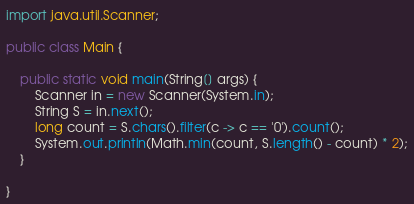Convert code to text. <code><loc_0><loc_0><loc_500><loc_500><_Java_>
import java.util.Scanner;

public class Main {

	public static void main(String[] args) {
		Scanner in = new Scanner(System.in);
		String S = in.next();
		long count = S.chars().filter(c -> c == '0').count();
		System.out.println(Math.min(count, S.length() - count) * 2);
	}

}
</code> 